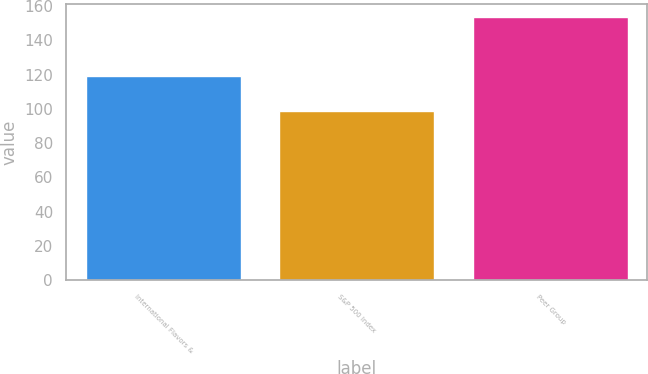Convert chart. <chart><loc_0><loc_0><loc_500><loc_500><bar_chart><fcel>International Flavors &<fcel>S&P 500 Index<fcel>Peer Group<nl><fcel>119.41<fcel>98.76<fcel>153.44<nl></chart> 